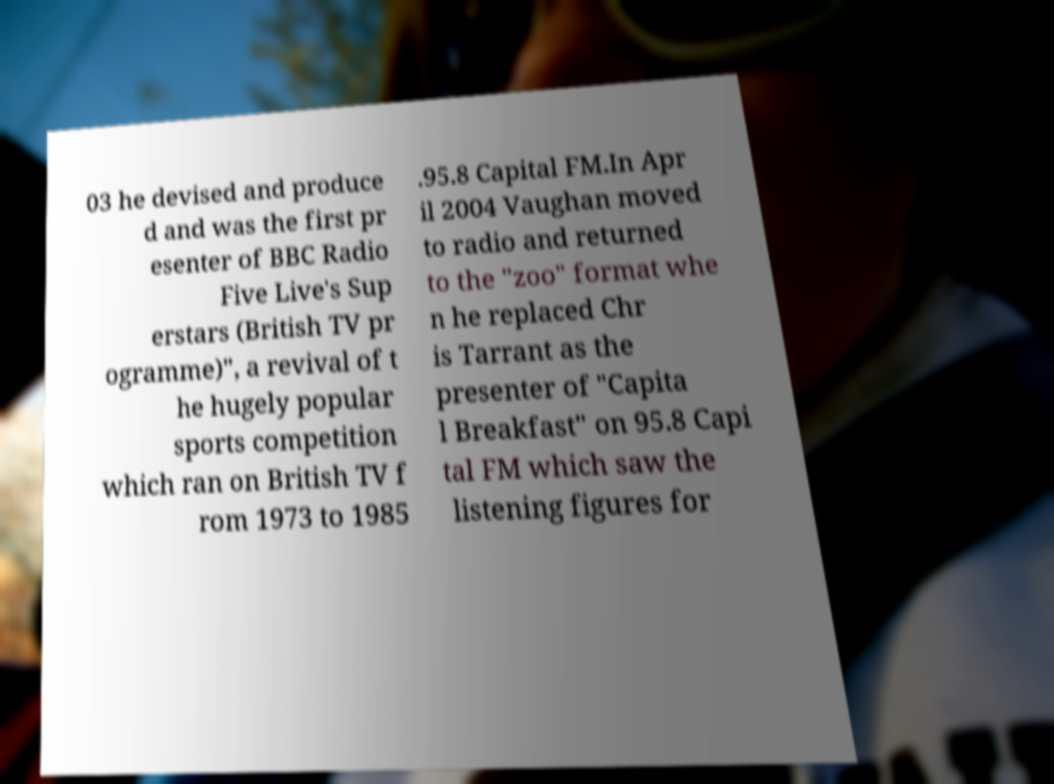Can you accurately transcribe the text from the provided image for me? 03 he devised and produce d and was the first pr esenter of BBC Radio Five Live's Sup erstars (British TV pr ogramme)", a revival of t he hugely popular sports competition which ran on British TV f rom 1973 to 1985 .95.8 Capital FM.In Apr il 2004 Vaughan moved to radio and returned to the "zoo" format whe n he replaced Chr is Tarrant as the presenter of "Capita l Breakfast" on 95.8 Capi tal FM which saw the listening figures for 